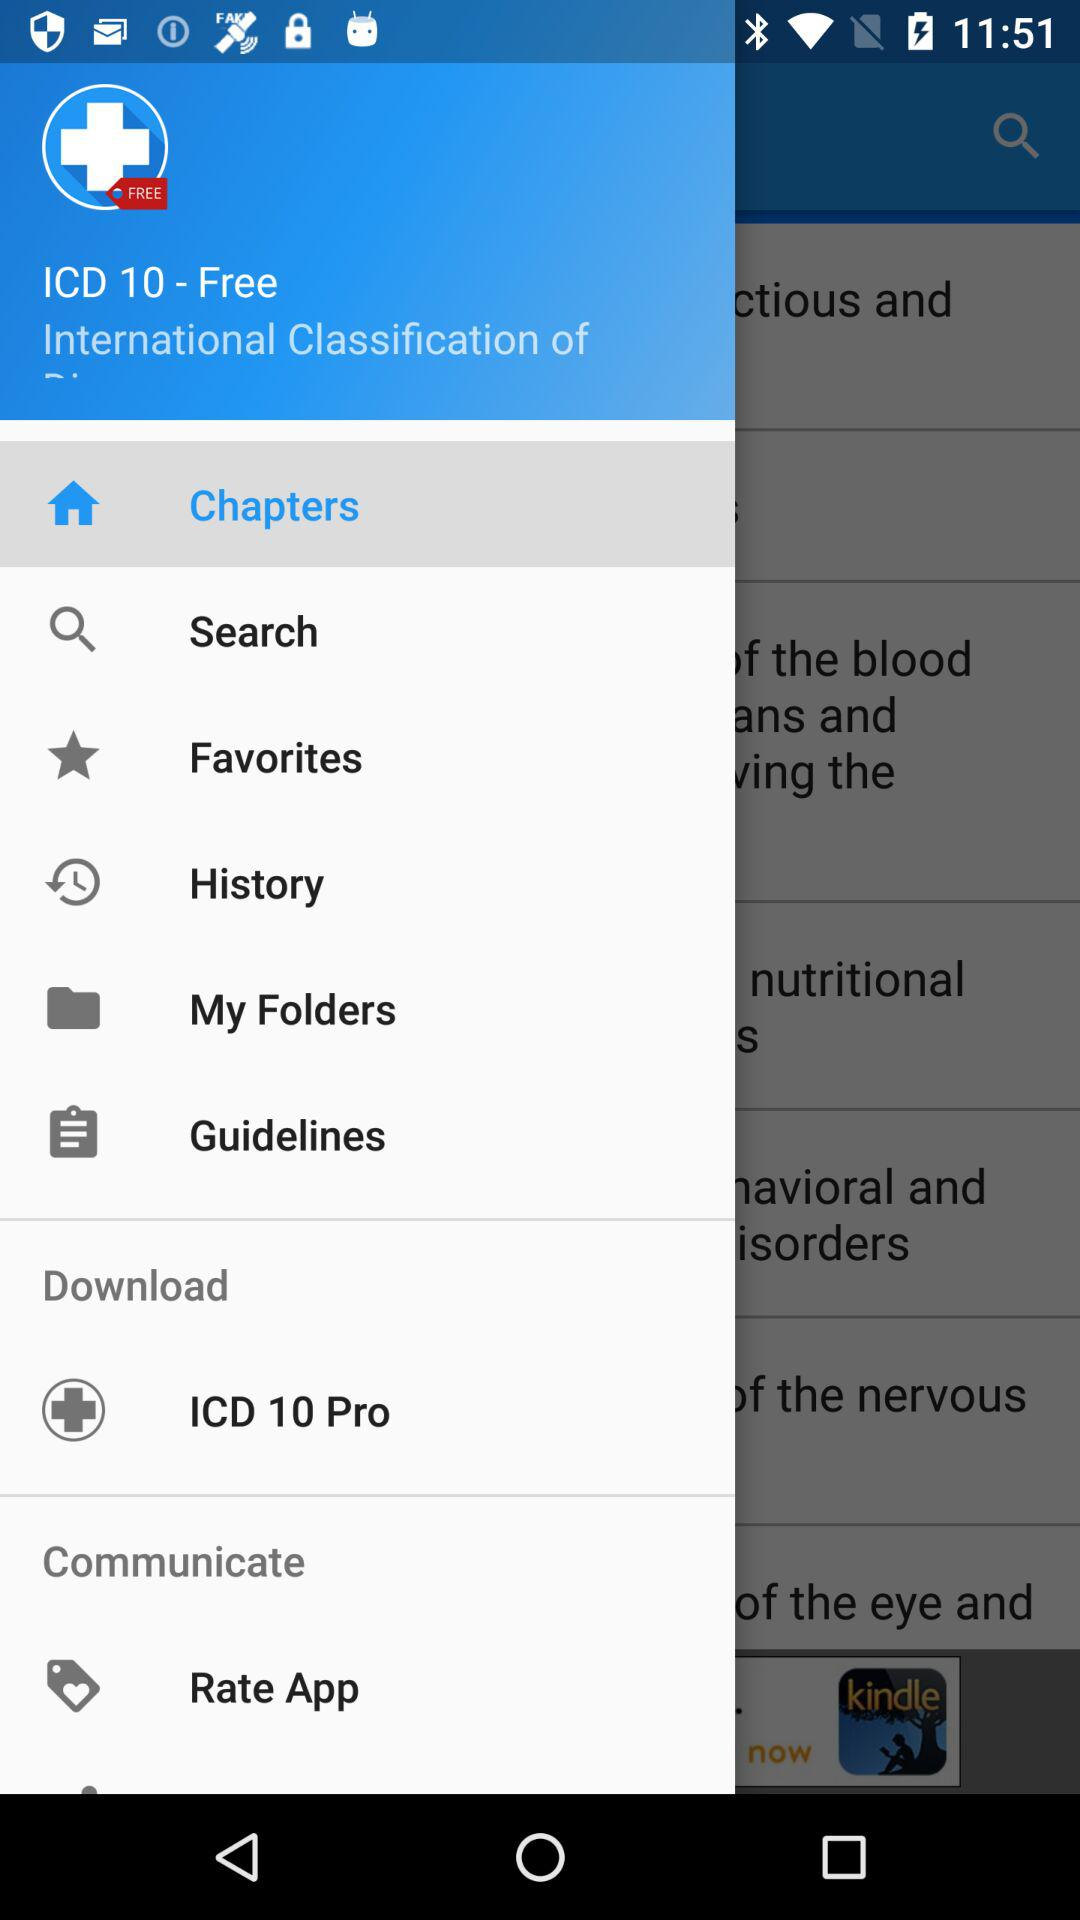Which item is selected? The selected item is "Chapters". 